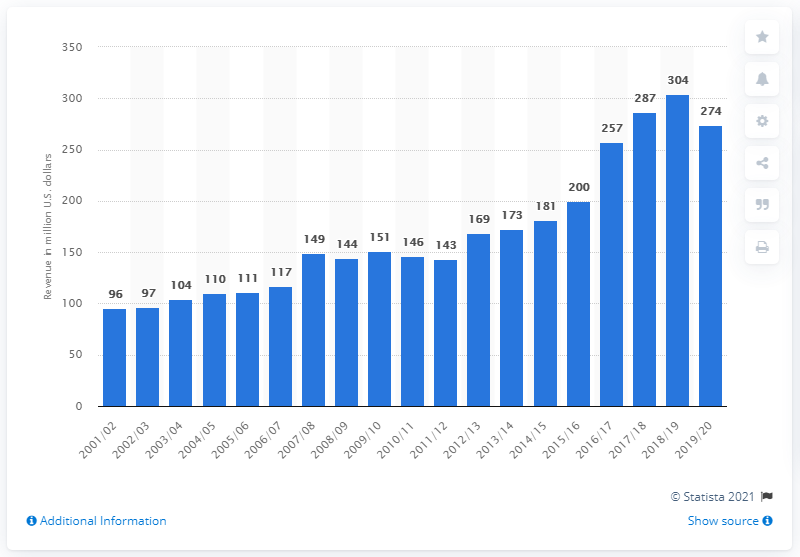Draw attention to some important aspects in this diagram. The Boston Celtics have not had a season since 2001/2002. The estimated revenue of the Boston Celtics in the 2019/2020 season was approximately 274 million U.S. dollars. The Boston Celtics franchise made a profit in the 2019/2020 season. 